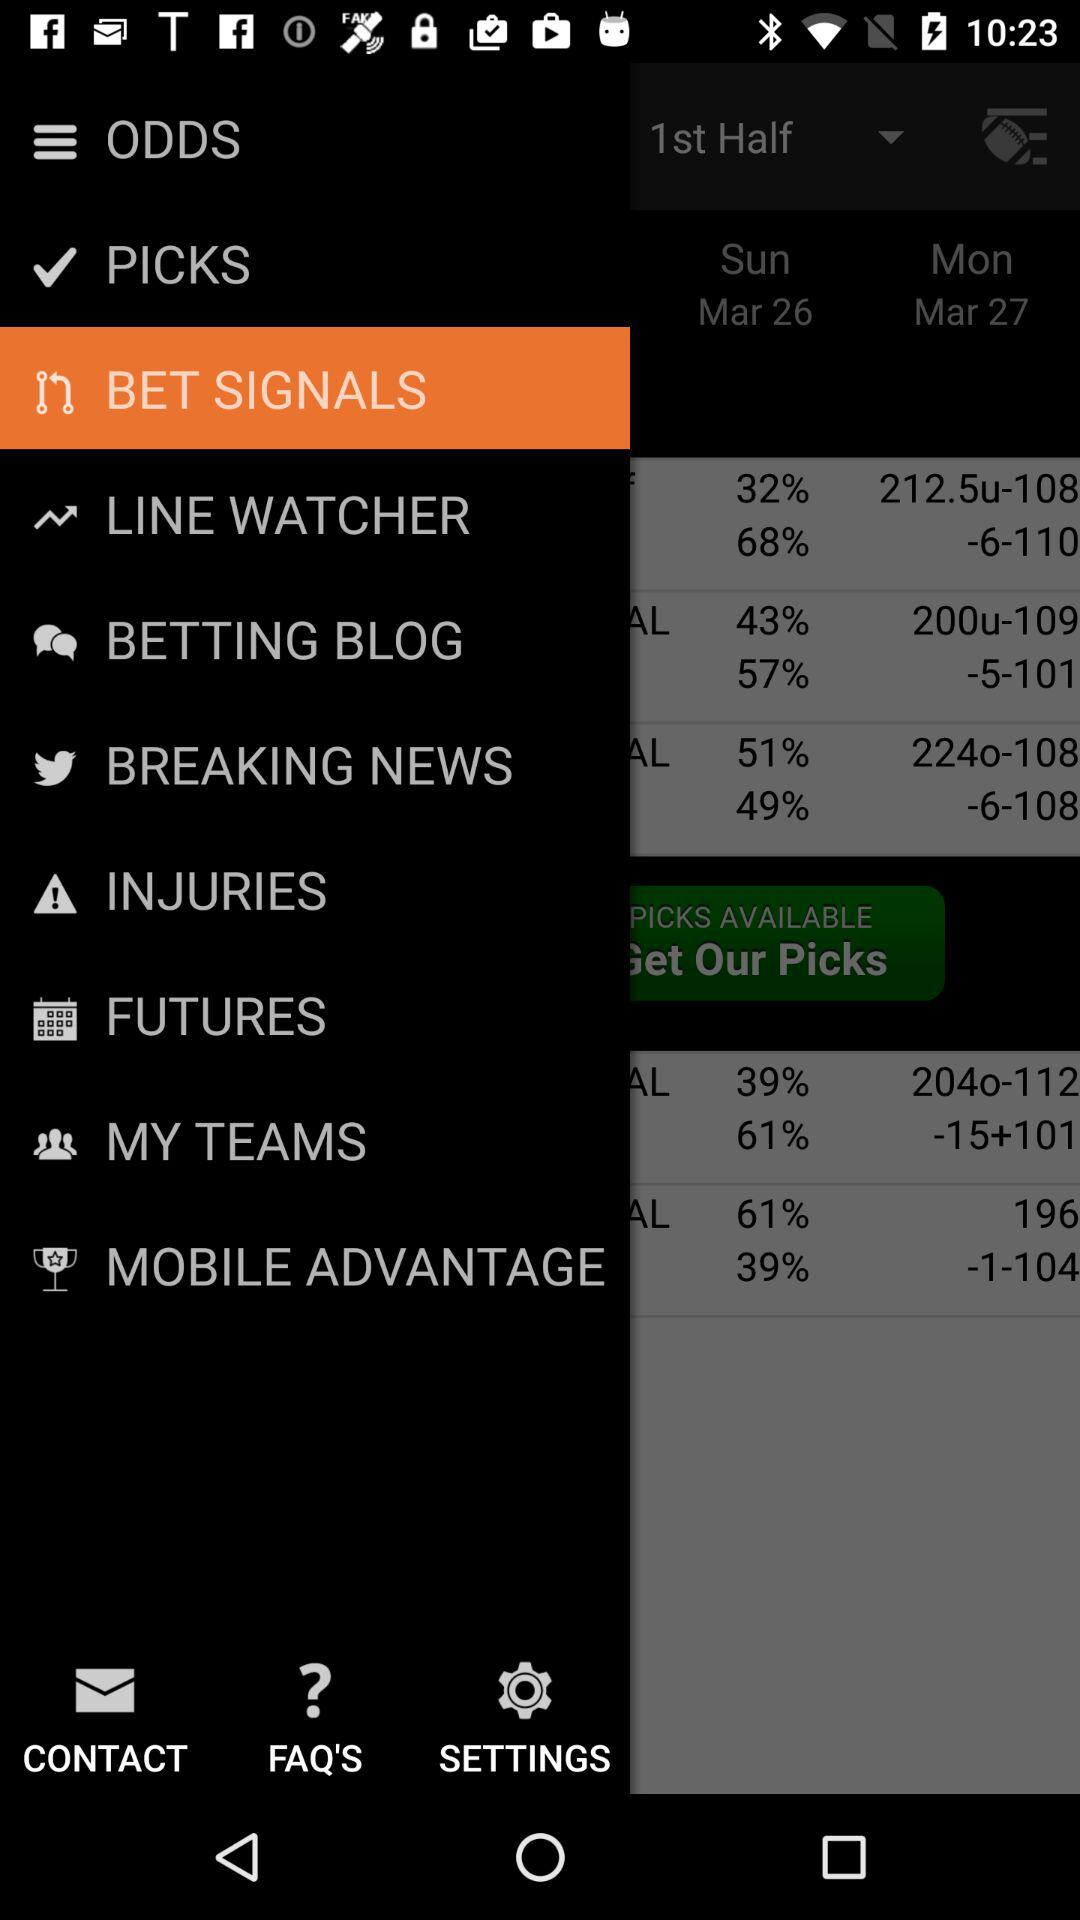Which option is selected? The selected option is "BET SIGNALS". 